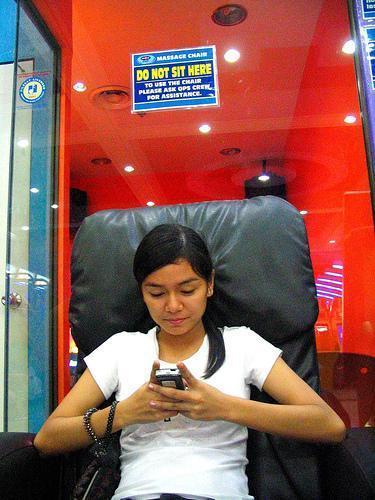How many people are in the picture?
Give a very brief answer. 1. 